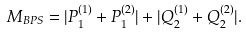Convert formula to latex. <formula><loc_0><loc_0><loc_500><loc_500>M _ { B P S } = | P ^ { ( 1 ) } _ { 1 } + P ^ { ( 2 ) } _ { 1 } | + | Q ^ { ( 1 ) } _ { 2 } + Q ^ { ( 2 ) } _ { 2 } | .</formula> 